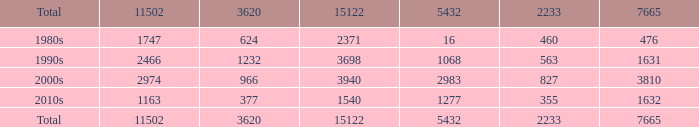Parse the table in full. {'header': ['Total', '11502', '3620', '15122', '5432', '2233', '7665'], 'rows': [['1980s', '1747', '624', '2371', '16', '460', '476'], ['1990s', '2466', '1232', '3698', '1068', '563', '1631'], ['2000s', '2974', '966', '3940', '2983', '827', '3810'], ['2010s', '1163', '377', '1540', '1277', '355', '1632'], ['Total', '11502', '3620', '15122', '5432', '2233', '7665']]} What is the standard 3620 value possessing a 5432 of 1277 and a 15122 lesser than 1540? None. 